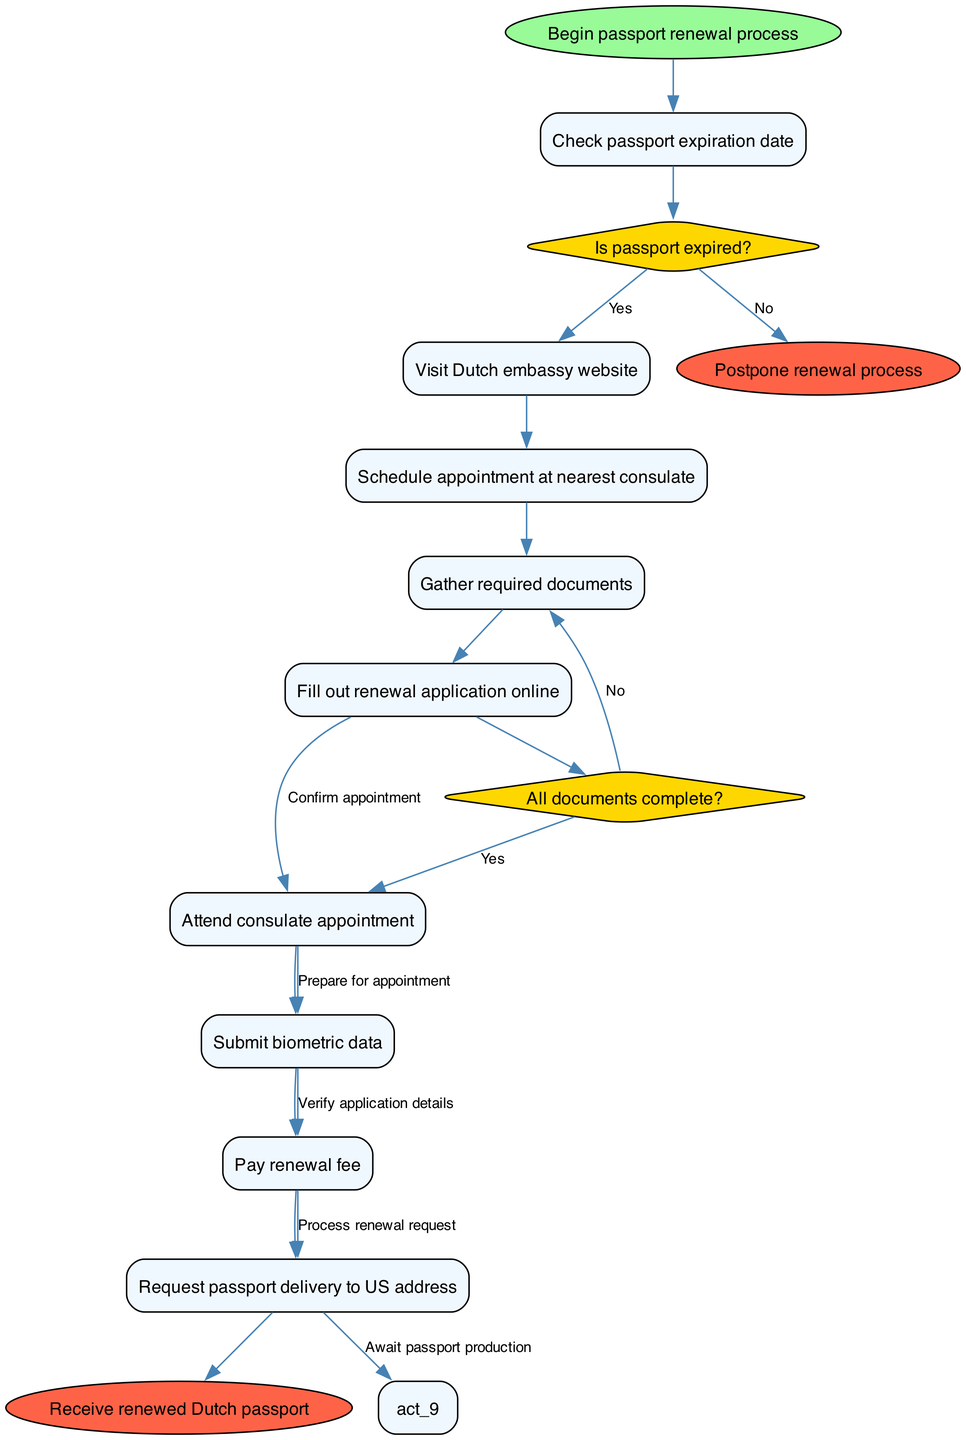What is the starting point of the process? The diagram clearly indicates that the process begins at the node labeled "Begin passport renewal process." This is the first node without any incoming edges, signifying the starting point of the entire activity flow.
Answer: Begin passport renewal process How many activities are listed in the diagram? The diagram contains a total of 8 activities, which are depicted as rectangular nodes. Activities are enumerated from the start of the process until the submission of biometric data.
Answer: 8 What is the first decision point encountered in the diagram? The first decision point in the diagram is found after checking the passport expiration date. It poses the question: "Is passport expired?" This decision is crucial in determining the flow of the renewal process.
Answer: Is passport expired? If the answer to the first decision is 'No', what is the subsequent action? If the answer to the question "Is passport expired?" is 'No,' the process flows directly to the end node labeled "Postpone renewal process." This indicates that the activity does not proceed to the next steps for renewal.
Answer: Postpone renewal process What happens if all documents are not complete? If the answer to the decision "All documents complete?" is 'No,' the process loops back to the activity "Gather required documents." This shows the need to ensure all required documents are in place before proceeding.
Answer: Gather required documents What is the final outcome if the entire renewal process is completed? Upon successful completion of the passport renewal process, the last node reached will be "Receive renewed Dutch passport." This indicates the desired result of the process.
Answer: Receive renewed Dutch passport How is the appointment confirmed in the diagram? The diagram illustrates that after scheduling the appointment at the nearest consulate, the next step involves confirming the appointment, represented by an edge connecting two activities.
Answer: Confirm appointment What represents a branching decision in the activity diagram? In the diagram, the diamond-shaped nodes represent branching decisions. Specifically, the questions like "Is passport expired?" and "All documents complete?" serve as decision points that dictate the subsequent flow based on yes or no answers.
Answer: Diamond-shaped nodes 